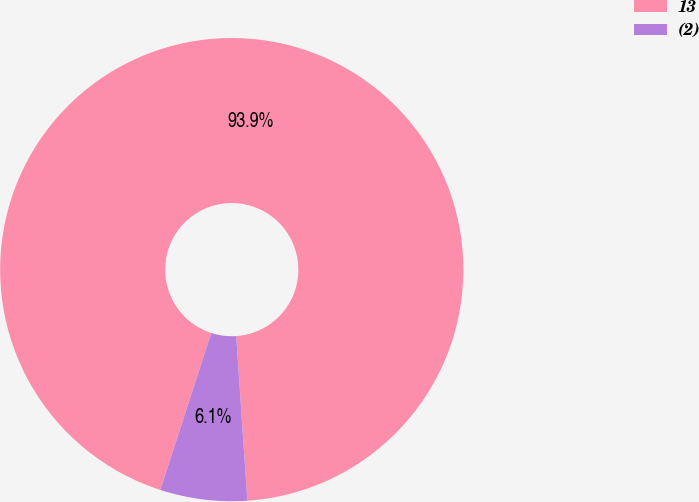Convert chart. <chart><loc_0><loc_0><loc_500><loc_500><pie_chart><fcel>13<fcel>(2)<nl><fcel>93.94%<fcel>6.06%<nl></chart> 